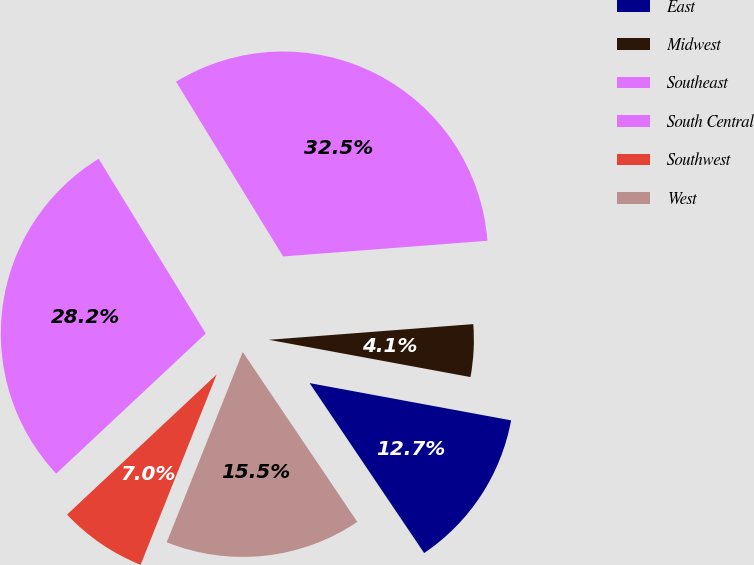Convert chart to OTSL. <chart><loc_0><loc_0><loc_500><loc_500><pie_chart><fcel>East<fcel>Midwest<fcel>Southeast<fcel>South Central<fcel>Southwest<fcel>West<nl><fcel>12.65%<fcel>4.13%<fcel>32.53%<fcel>28.23%<fcel>6.97%<fcel>15.49%<nl></chart> 